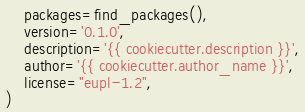Convert code to text. <code><loc_0><loc_0><loc_500><loc_500><_Python_>    packages=find_packages(),
    version='0.1.0',
    description='{{ cookiecutter.description }}',
    author='{{ cookiecutter.author_name }}',
    license="eupl-1.2",
)
</code> 